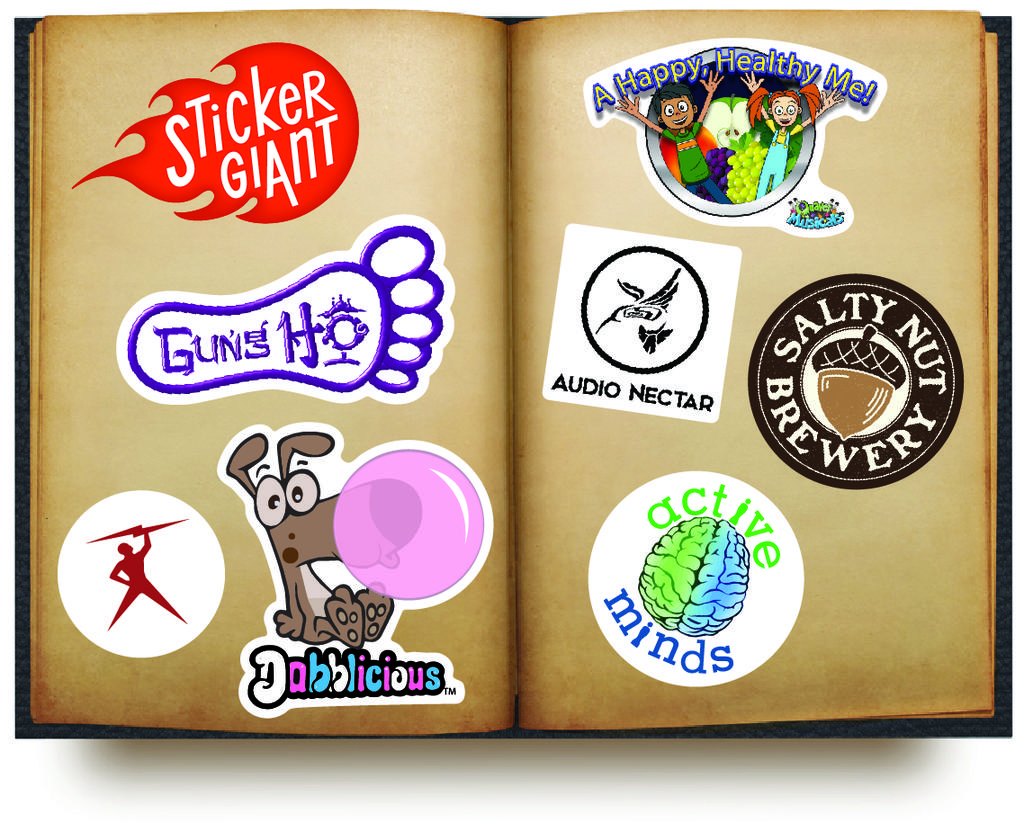What object can be seen in the image? There is a book in the image. What is unique about the appearance of the book? The book has stickers pasted on it. What type of cake is being served at the book's birthday party in the image? There is no cake or birthday party present in the image; it only features a book with stickers. 